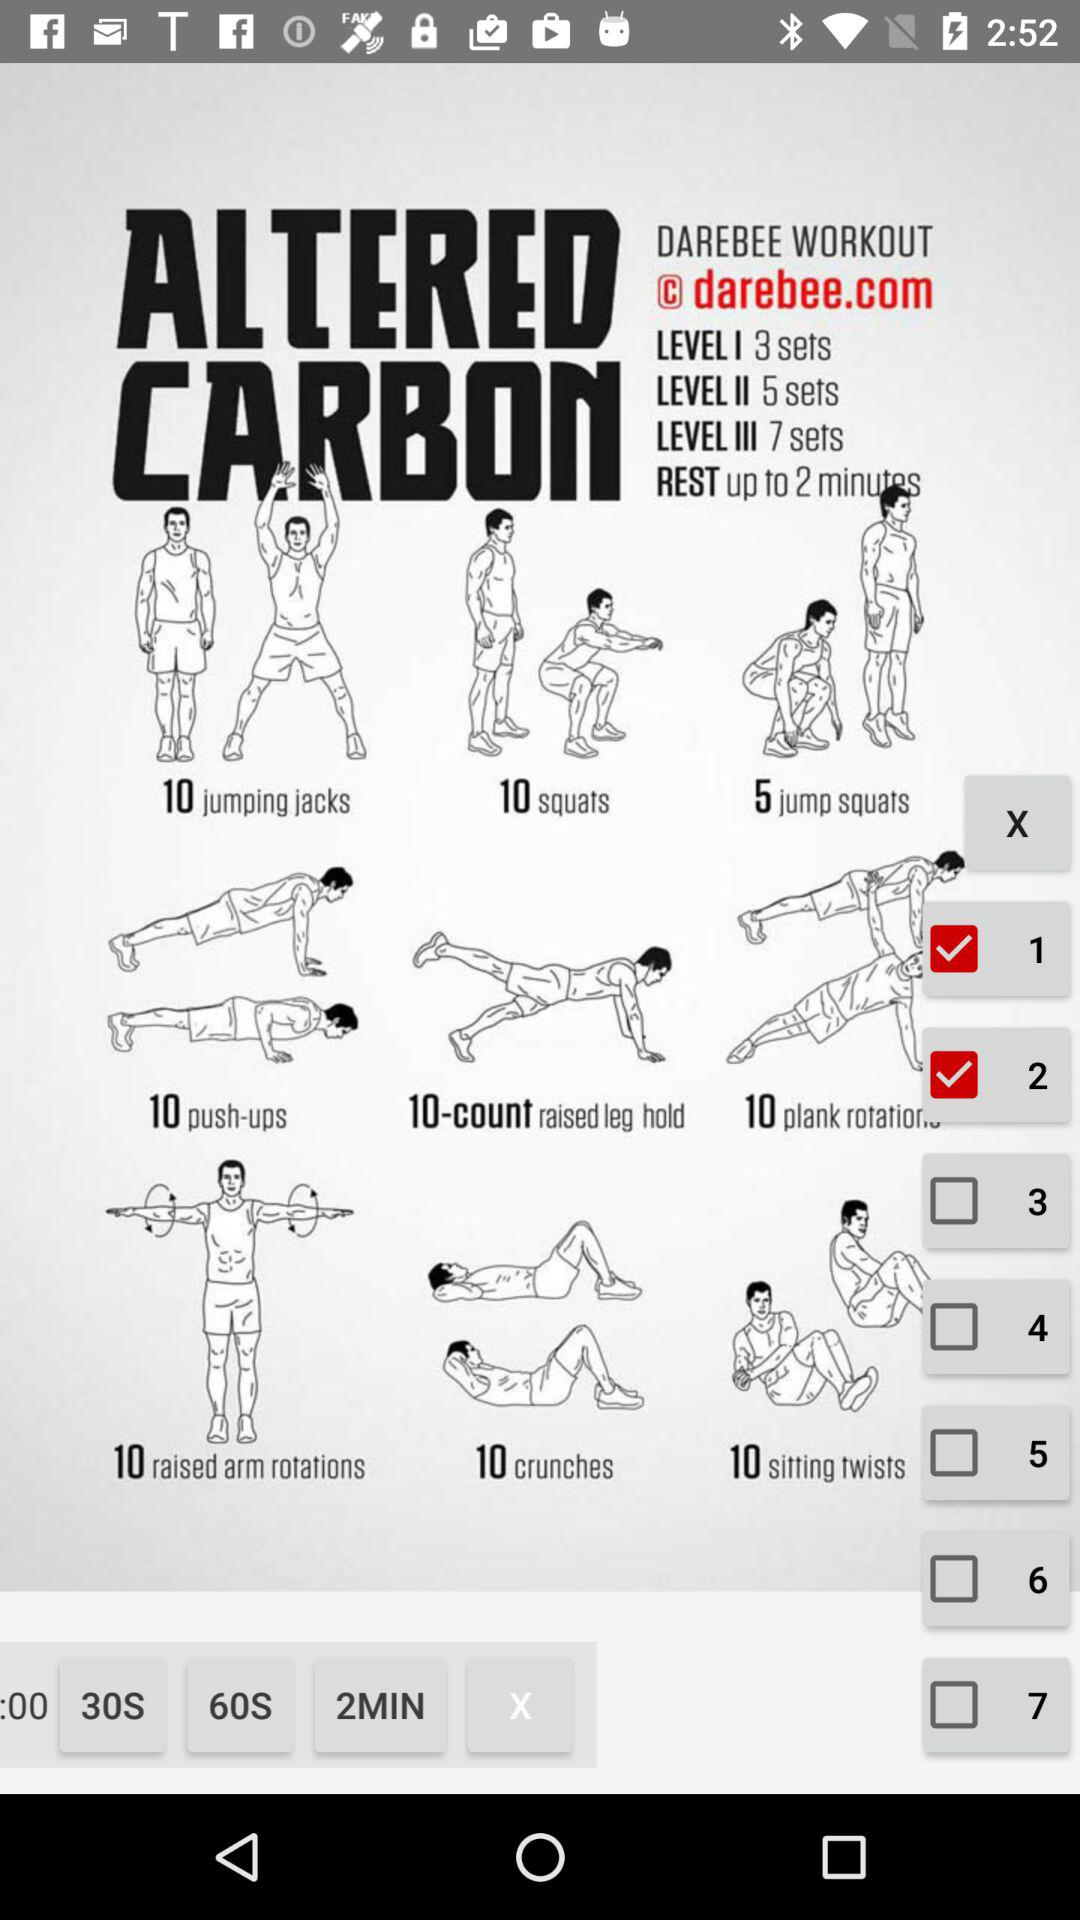What is the number of sets in level one? The number of sets in level one is 3. 